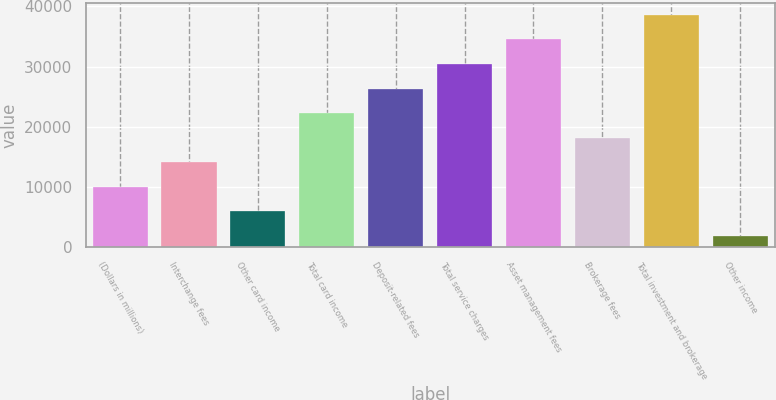<chart> <loc_0><loc_0><loc_500><loc_500><bar_chart><fcel>(Dollars in millions)<fcel>Interchange fees<fcel>Other card income<fcel>Total card income<fcel>Deposit-related fees<fcel>Total service charges<fcel>Asset management fees<fcel>Brokerage fees<fcel>Total investment and brokerage<fcel>Other income<nl><fcel>10009.8<fcel>14094.2<fcel>5925.4<fcel>22263<fcel>26347.4<fcel>30431.8<fcel>34516.2<fcel>18178.6<fcel>38600.6<fcel>1841<nl></chart> 